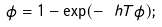Convert formula to latex. <formula><loc_0><loc_0><loc_500><loc_500>\phi = 1 - \exp ( - \ h T \phi ) ;</formula> 